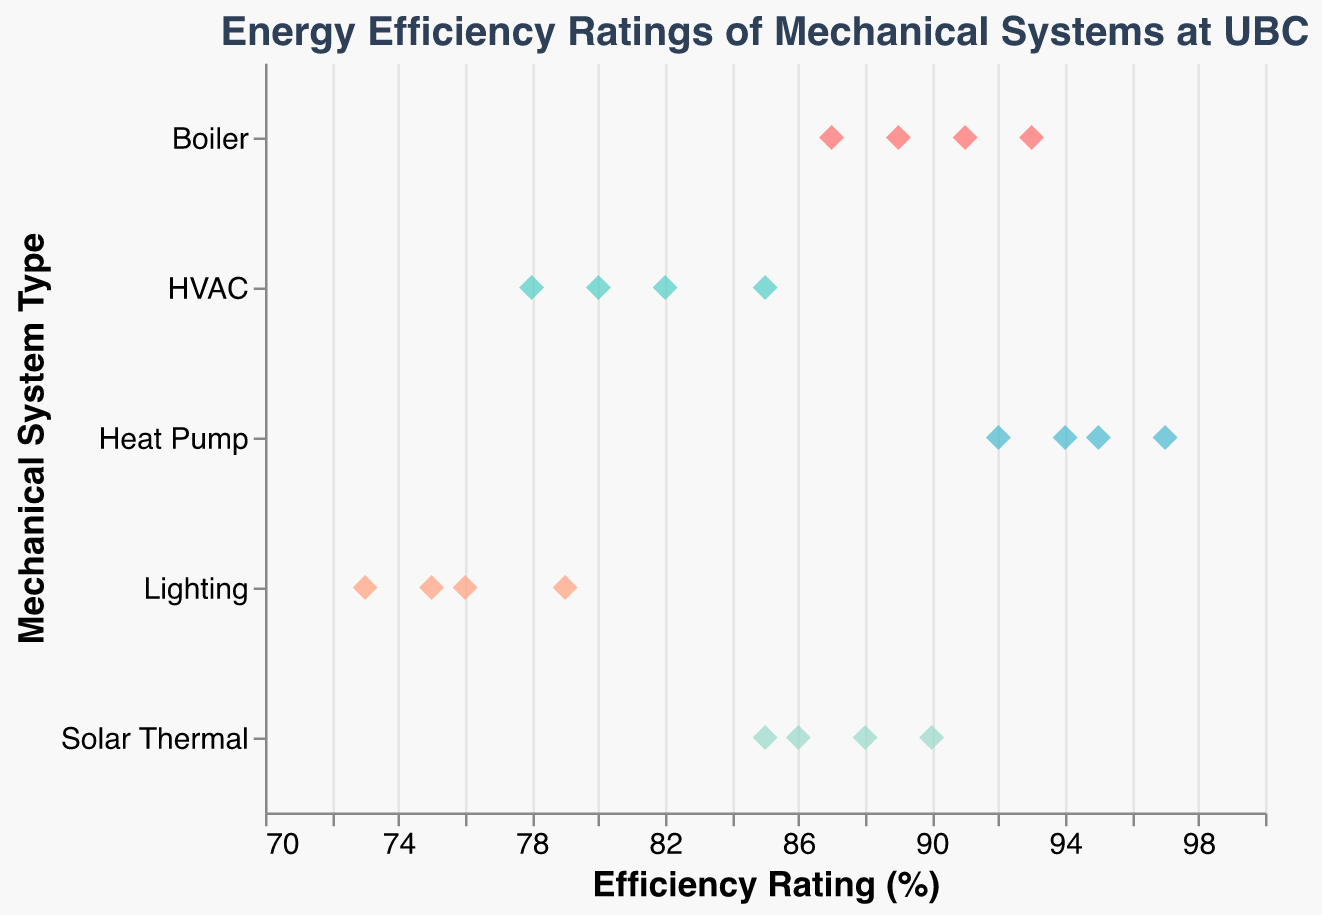What is the maximum efficiency rating for the Heat Pump systems? From the figure, look at the highest point in the "Heat Pump" row, which represents the maximum efficiency rating.
Answer: 97 How many data points are there for the Lighting system? Count the number of points in the "Lighting" row.
Answer: 4 Which mechanical system type shows the lowest efficiency rating? Identify the lowest point among all rows, then refer to which mechanical system it belongs.
Answer: Lighting What is the average efficiency rating of the Boiler systems? Sum the efficiency ratings for the Boiler systems (91+89+93+87), and divide by the number of data points, which is 4. (91+89+93+87)/4 = 90
Answer: 90 Do the HVAC systems have any efficiency rating above 85? Check the "HVAC" row for any points with a value above 85.
Answer: No What is the range of efficiency ratings for the Solar Thermal systems? Find the maximum and minimum values in the "Solar Thermal" row and calculate the difference. Range: 90 - 85 = 5
Answer: 5 Compare the median efficiency rating of the Heat Pump to that of the HVAC systems. Determine the median of the "Heat Pump" and "HVAC" rows. For "Heat Pump" (92+94)/2 = 93. For "HVAC" (80+82)/2 = 81. Compare 93 to 81.
Answer: Heat Pump systems have a higher median efficiency rating Which systems have all their efficiency ratings above 85? Check each system's row and see which have all points above 85.
Answer: Boiler, Heat Pump, Solar Thermal How many mechanical system types are represented in the plot? Count the unique system types in the "System Type" column (HVAC, Boiler, Heat Pump, Solar Thermal, Lighting).
Answer: 5 What is the difference between the highest and lowest efficiency ratings for the Lighting systems? Identify the highest and lowest points in the "Lighting" row and calculate the difference. Difference: 79 - 73 = 6
Answer: 6 